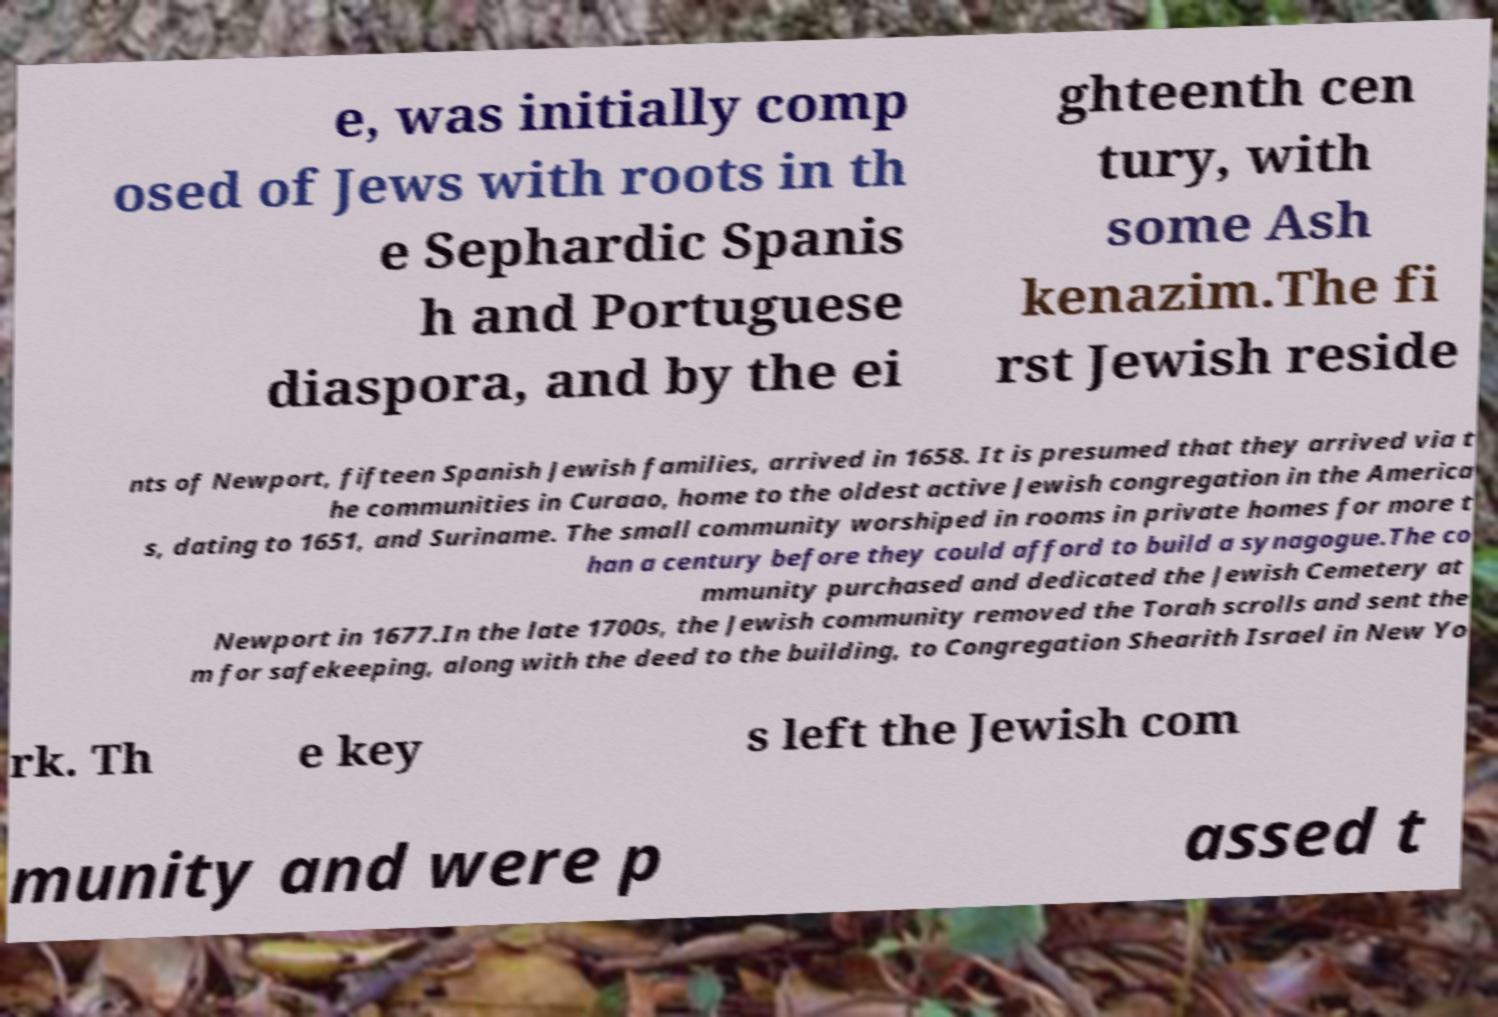Can you read and provide the text displayed in the image?This photo seems to have some interesting text. Can you extract and type it out for me? e, was initially comp osed of Jews with roots in th e Sephardic Spanis h and Portuguese diaspora, and by the ei ghteenth cen tury, with some Ash kenazim.The fi rst Jewish reside nts of Newport, fifteen Spanish Jewish families, arrived in 1658. It is presumed that they arrived via t he communities in Curaao, home to the oldest active Jewish congregation in the America s, dating to 1651, and Suriname. The small community worshiped in rooms in private homes for more t han a century before they could afford to build a synagogue.The co mmunity purchased and dedicated the Jewish Cemetery at Newport in 1677.In the late 1700s, the Jewish community removed the Torah scrolls and sent the m for safekeeping, along with the deed to the building, to Congregation Shearith Israel in New Yo rk. Th e key s left the Jewish com munity and were p assed t 